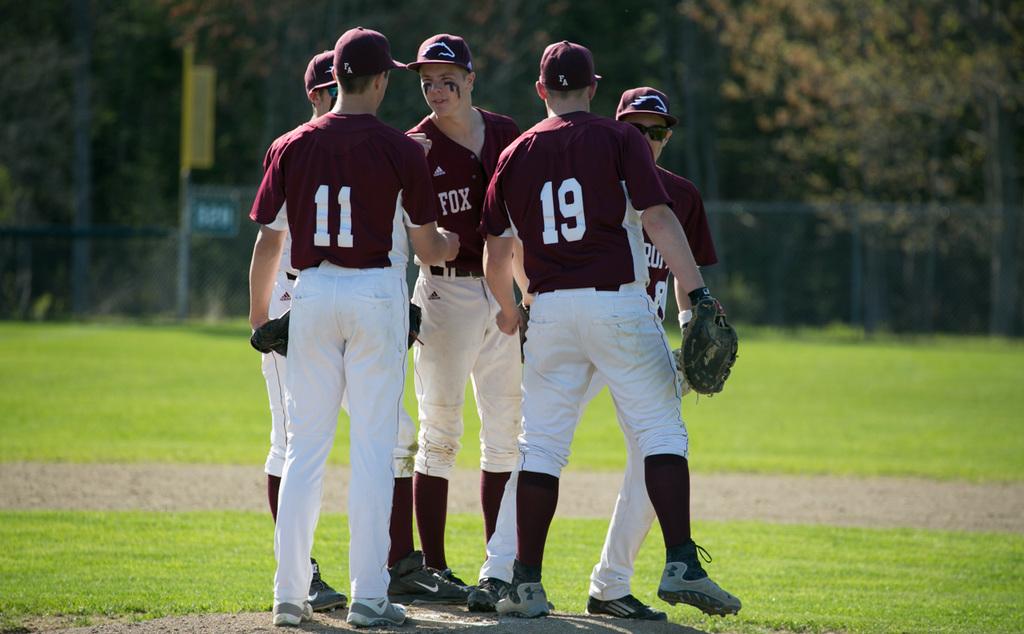Which player number appears to be shaking hands?
Give a very brief answer. 11. What two team members nubmers can be seen?
Ensure brevity in your answer.  11 and 19. 